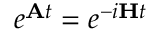Convert formula to latex. <formula><loc_0><loc_0><loc_500><loc_500>e ^ { A t } = e ^ { - i H t }</formula> 